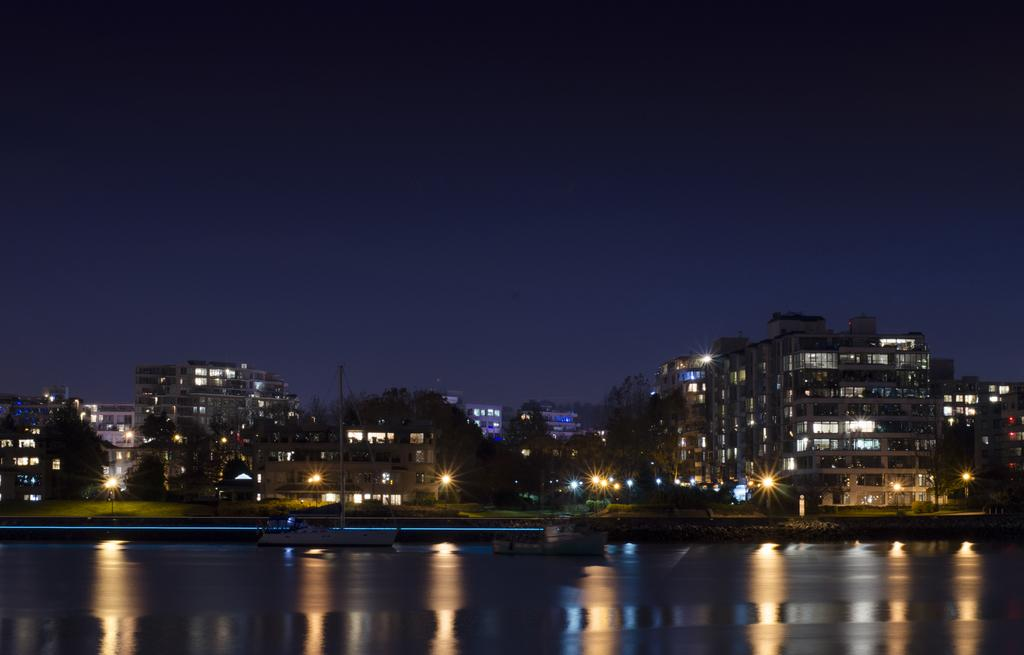What type of structures can be seen in the image? There are buildings in the image. What type of lighting is present in the image? Street lights are present in the image. What natural element is visible in the image? There is water visible in the image. What can be seen in the background of the image? The sky is visible in the background of the image. Where is the deer located in the image? There is no deer present in the image. What type of medical facility is visible in the image? There is no hospital or medical facility visible in the image. 